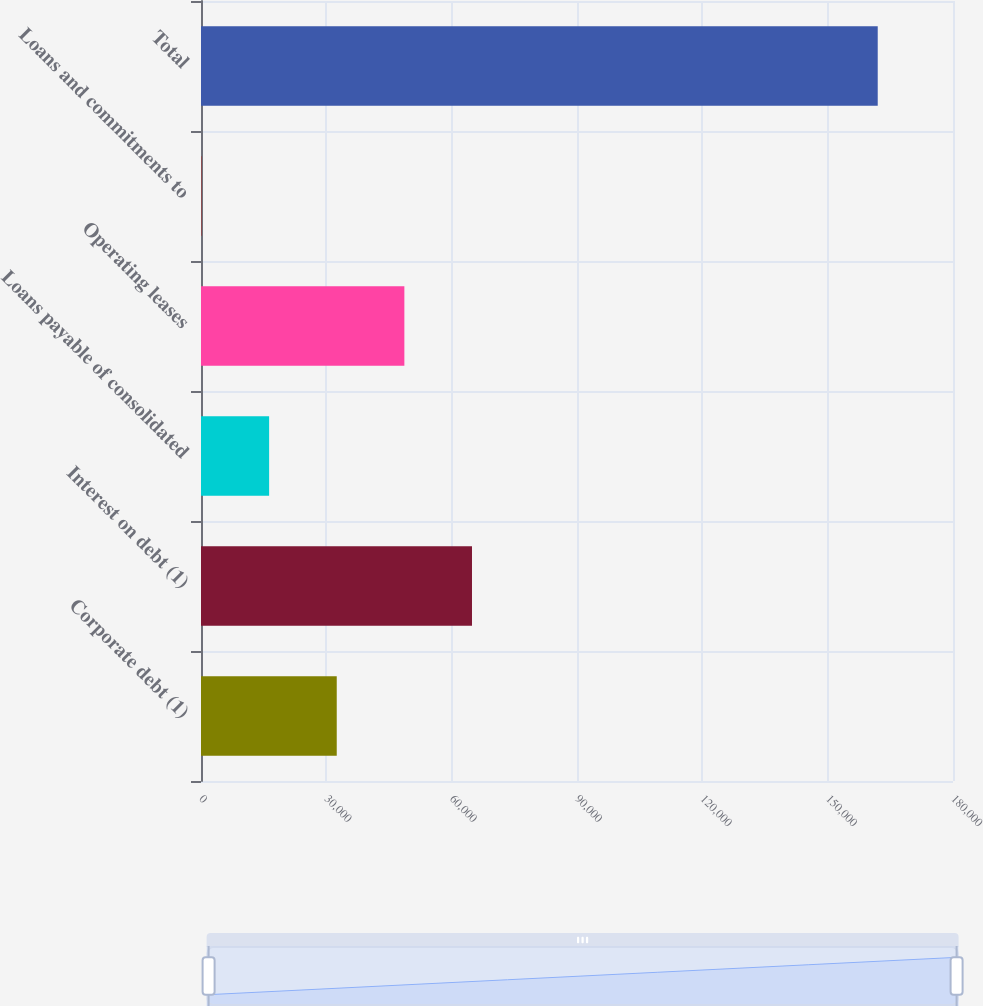Convert chart. <chart><loc_0><loc_0><loc_500><loc_500><bar_chart><fcel>Corporate debt (1)<fcel>Interest on debt (1)<fcel>Loans payable of consolidated<fcel>Operating leases<fcel>Loans and commitments to<fcel>Total<nl><fcel>32491.8<fcel>64864.6<fcel>16305.4<fcel>48678.2<fcel>119<fcel>161983<nl></chart> 